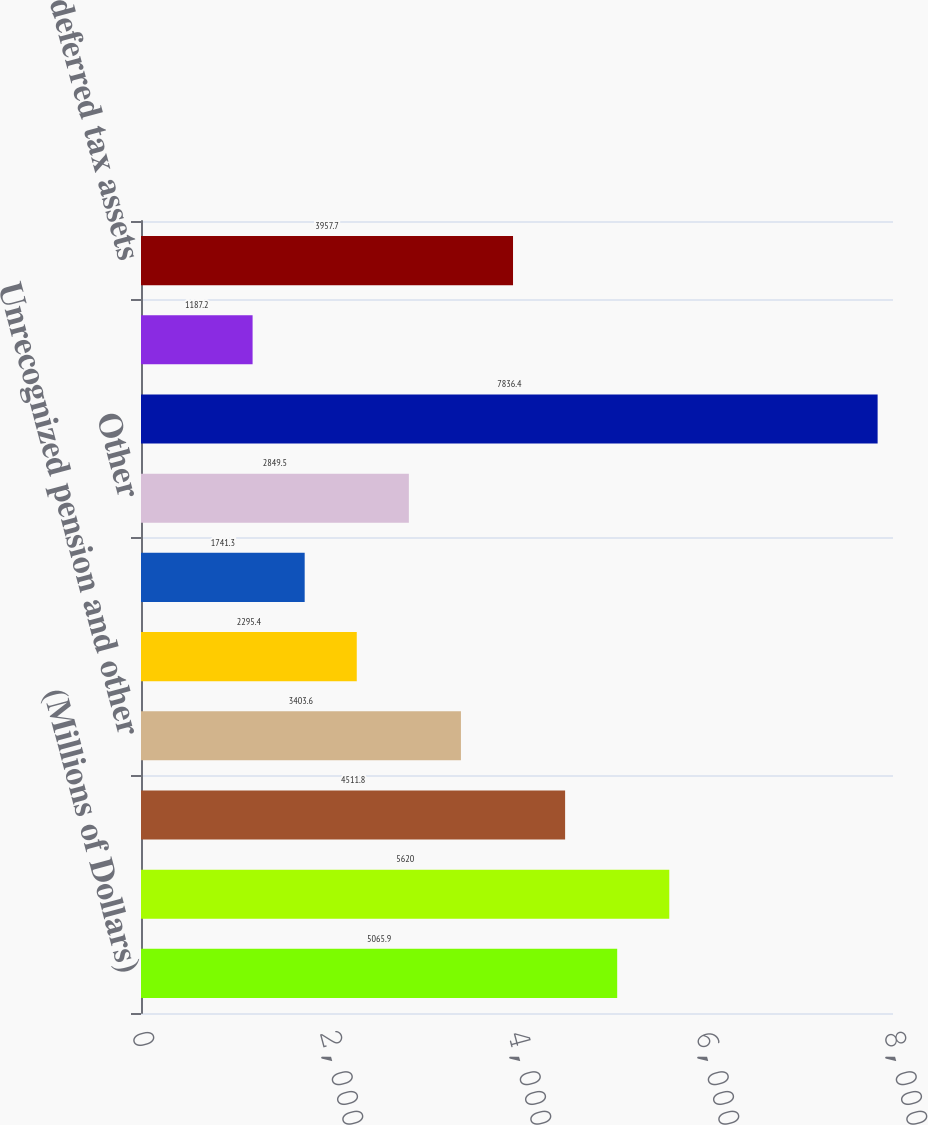<chart> <loc_0><loc_0><loc_500><loc_500><bar_chart><fcel>(Millions of Dollars)<fcel>Depreciation<fcel>Regulatory liability - future<fcel>Unrecognized pension and other<fcel>State income tax<fcel>Capitalized overheads<fcel>Other<fcel>Total deferred tax liabilities<fcel>Regulatory asset - future<fcel>Total deferred tax assets<nl><fcel>5065.9<fcel>5620<fcel>4511.8<fcel>3403.6<fcel>2295.4<fcel>1741.3<fcel>2849.5<fcel>7836.4<fcel>1187.2<fcel>3957.7<nl></chart> 